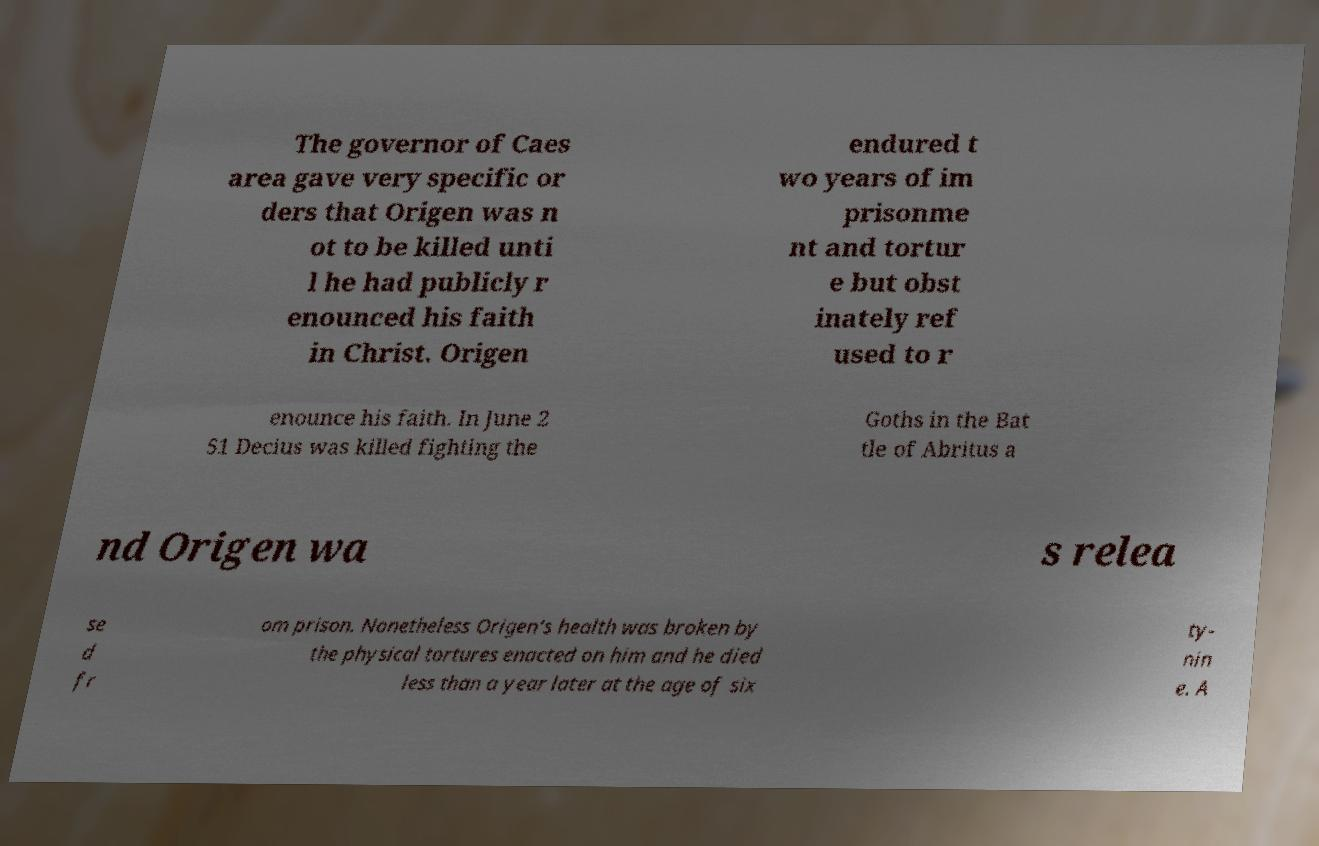Please read and relay the text visible in this image. What does it say? The governor of Caes area gave very specific or ders that Origen was n ot to be killed unti l he had publicly r enounced his faith in Christ. Origen endured t wo years of im prisonme nt and tortur e but obst inately ref used to r enounce his faith. In June 2 51 Decius was killed fighting the Goths in the Bat tle of Abritus a nd Origen wa s relea se d fr om prison. Nonetheless Origen's health was broken by the physical tortures enacted on him and he died less than a year later at the age of six ty- nin e. A 